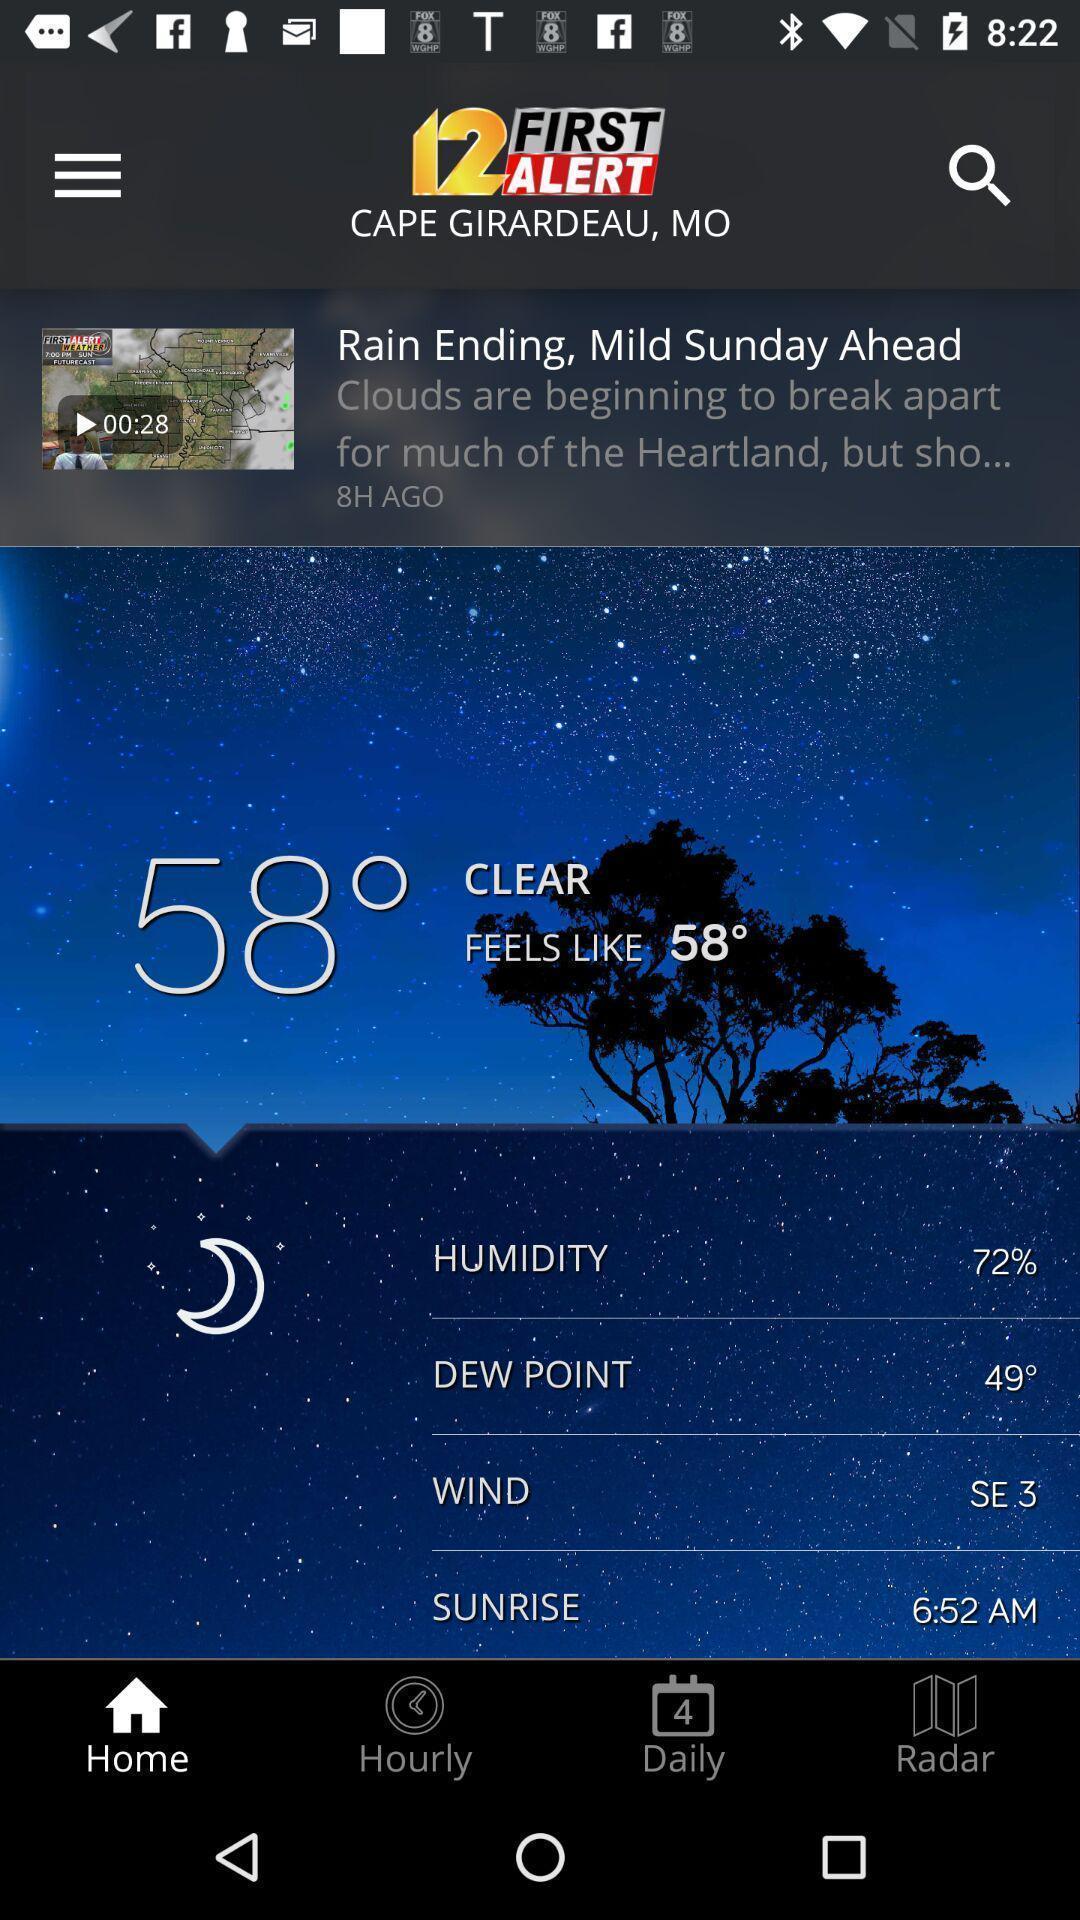Explain the elements present in this screenshot. Screen displaying multiple options in a weather application. 